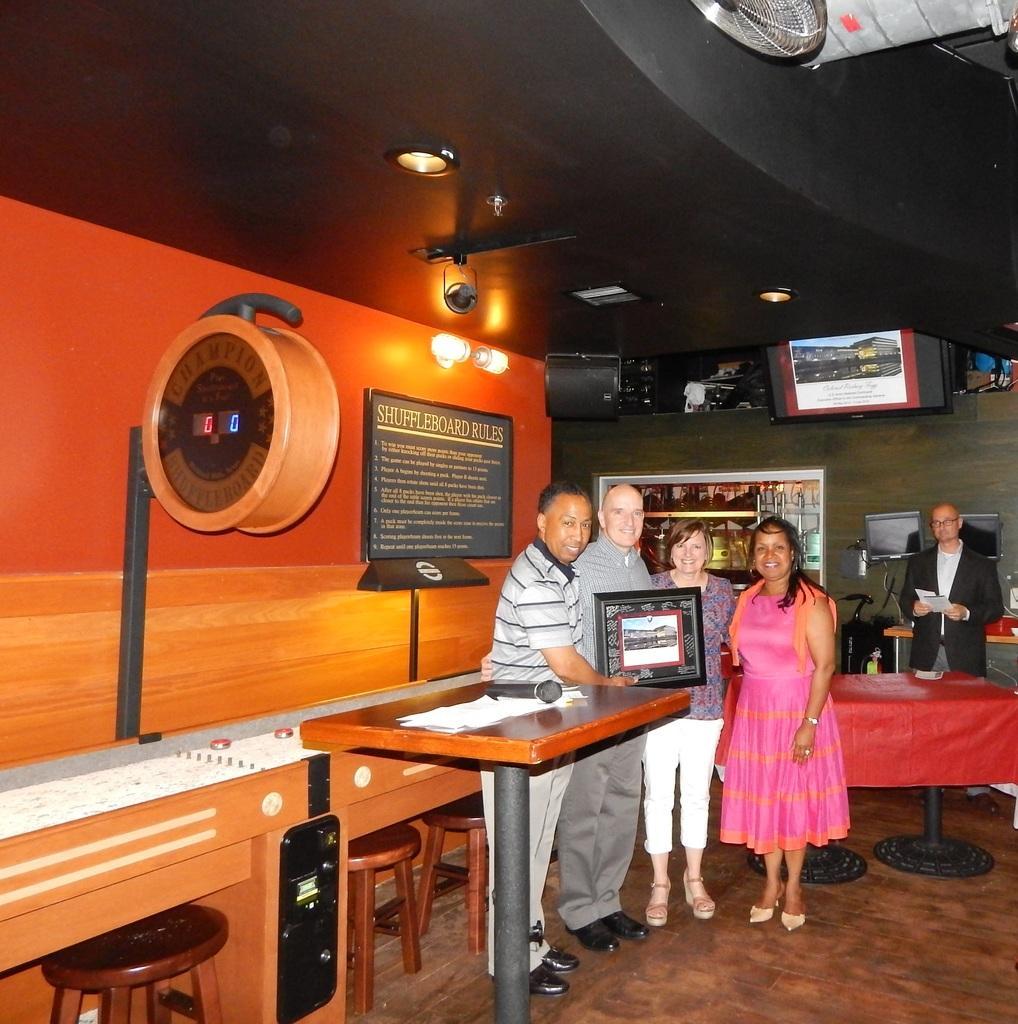In one or two sentences, can you explain what this image depicts? There are four members standing and posing for a picture. One of the guy is holding a frame in his hands. In front of them, there is a table on which some papers were there. In the background there is another man standing and we can observe a televisions and a wall here. 